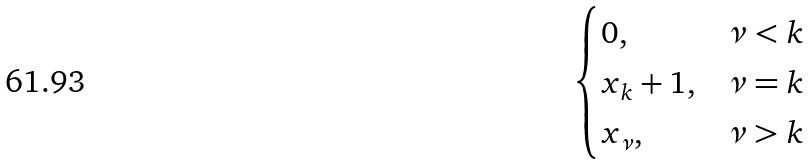<formula> <loc_0><loc_0><loc_500><loc_500>\begin{cases} 0 , & \nu < k \\ x _ { k } + 1 , & \nu = k \\ x _ { \nu } , & \nu > k \end{cases}</formula> 